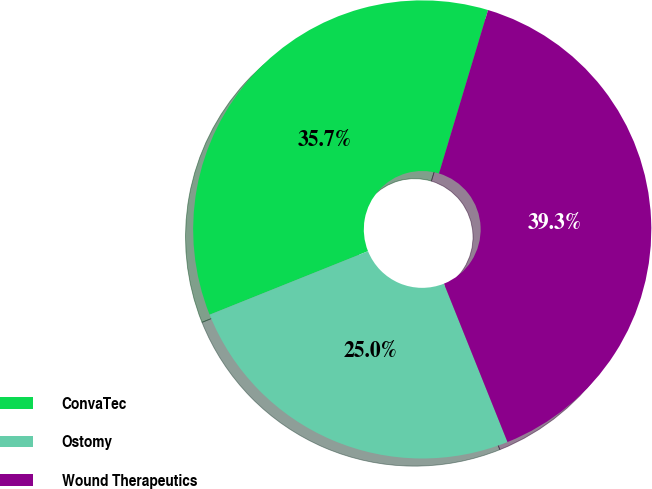<chart> <loc_0><loc_0><loc_500><loc_500><pie_chart><fcel>ConvaTec<fcel>Ostomy<fcel>Wound Therapeutics<nl><fcel>35.71%<fcel>25.0%<fcel>39.29%<nl></chart> 